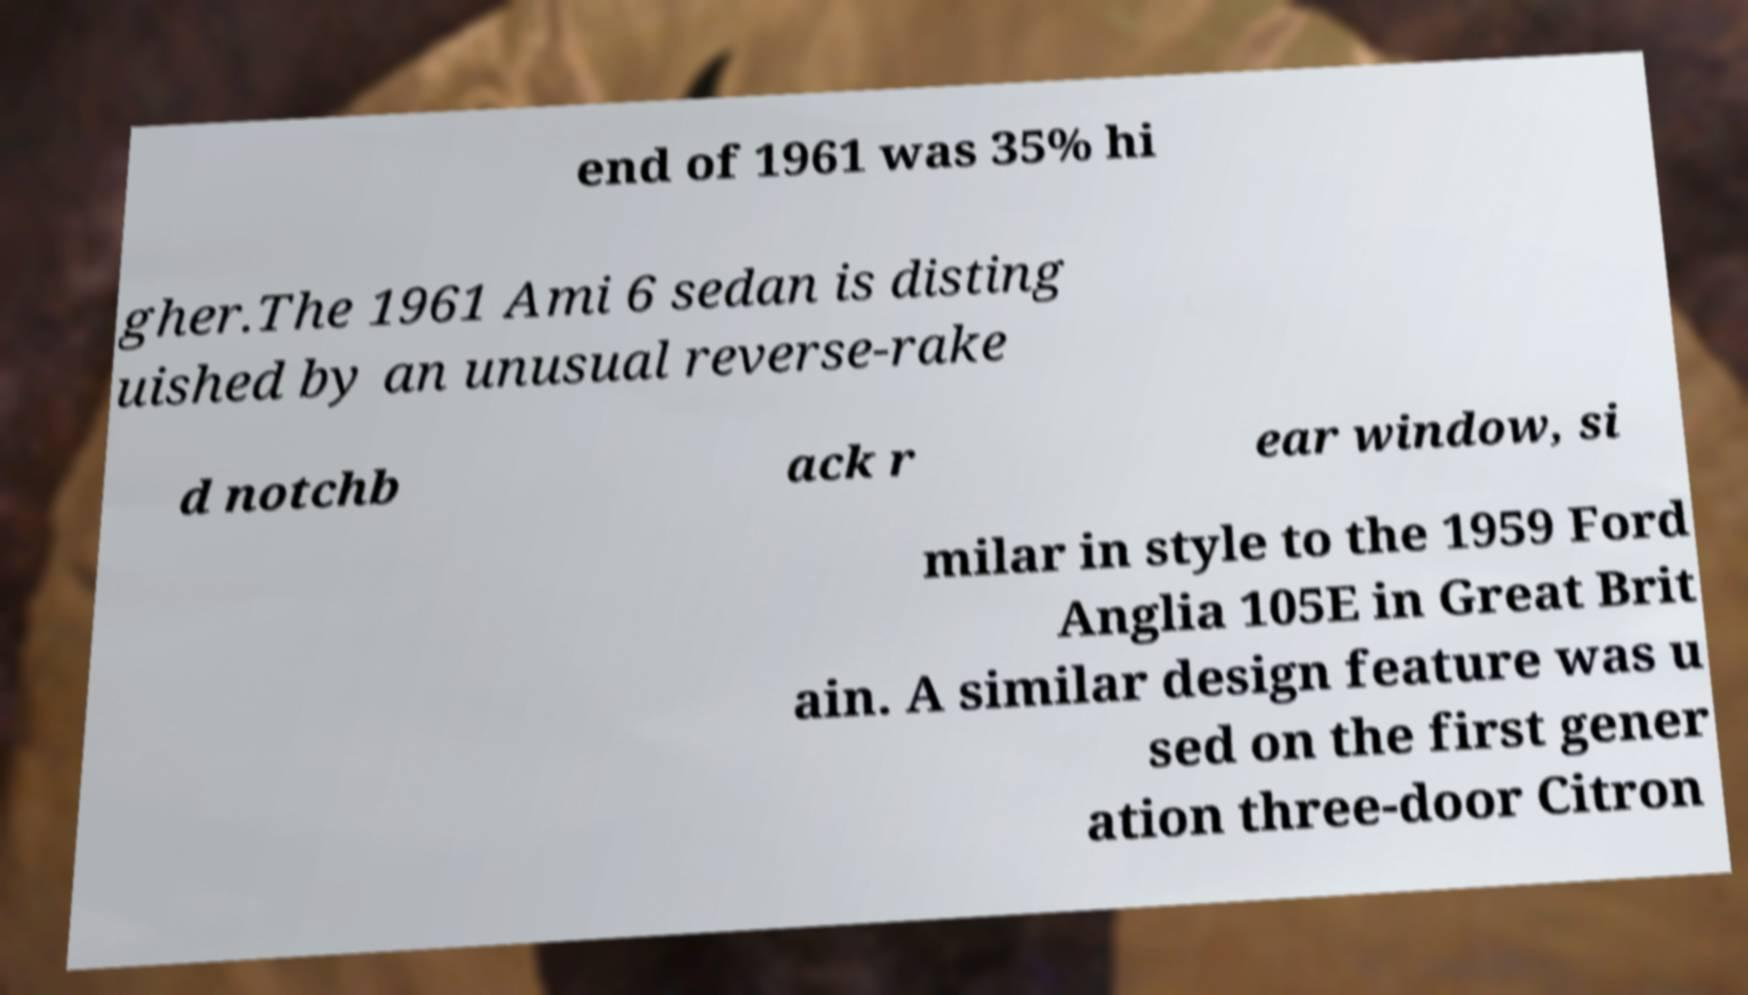What messages or text are displayed in this image? I need them in a readable, typed format. end of 1961 was 35% hi gher.The 1961 Ami 6 sedan is disting uished by an unusual reverse-rake d notchb ack r ear window, si milar in style to the 1959 Ford Anglia 105E in Great Brit ain. A similar design feature was u sed on the first gener ation three-door Citron 